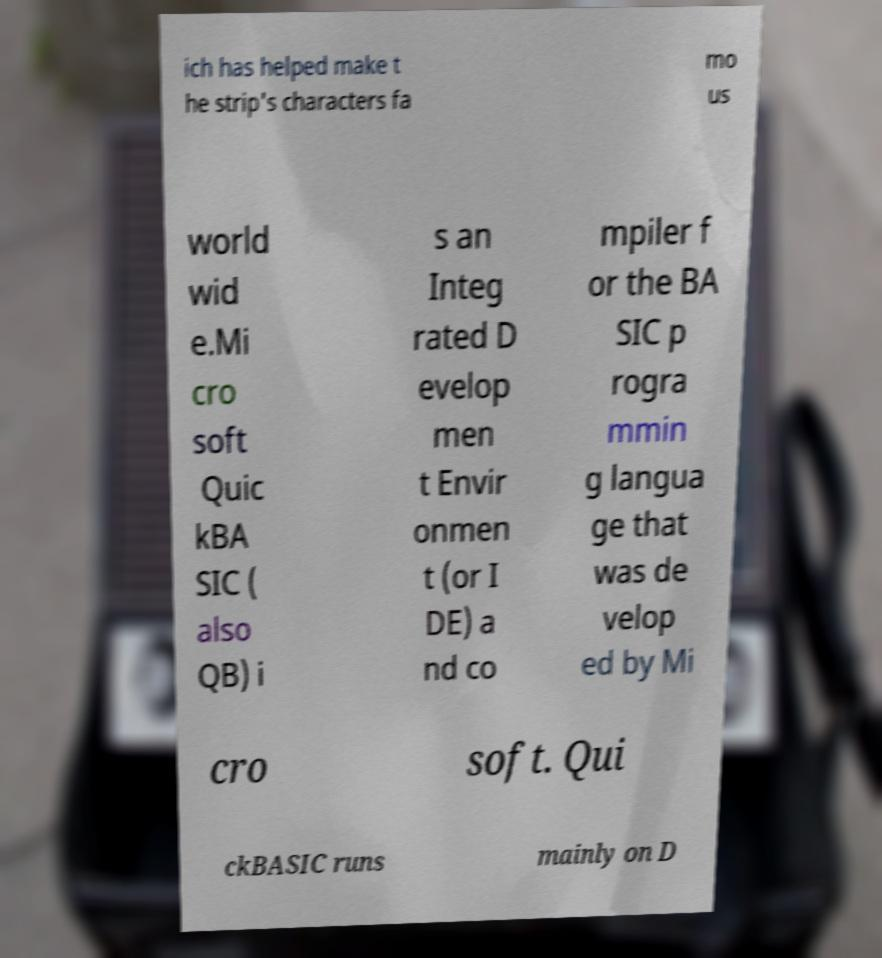Can you read and provide the text displayed in the image?This photo seems to have some interesting text. Can you extract and type it out for me? ich has helped make t he strip's characters fa mo us world wid e.Mi cro soft Quic kBA SIC ( also QB) i s an Integ rated D evelop men t Envir onmen t (or I DE) a nd co mpiler f or the BA SIC p rogra mmin g langua ge that was de velop ed by Mi cro soft. Qui ckBASIC runs mainly on D 